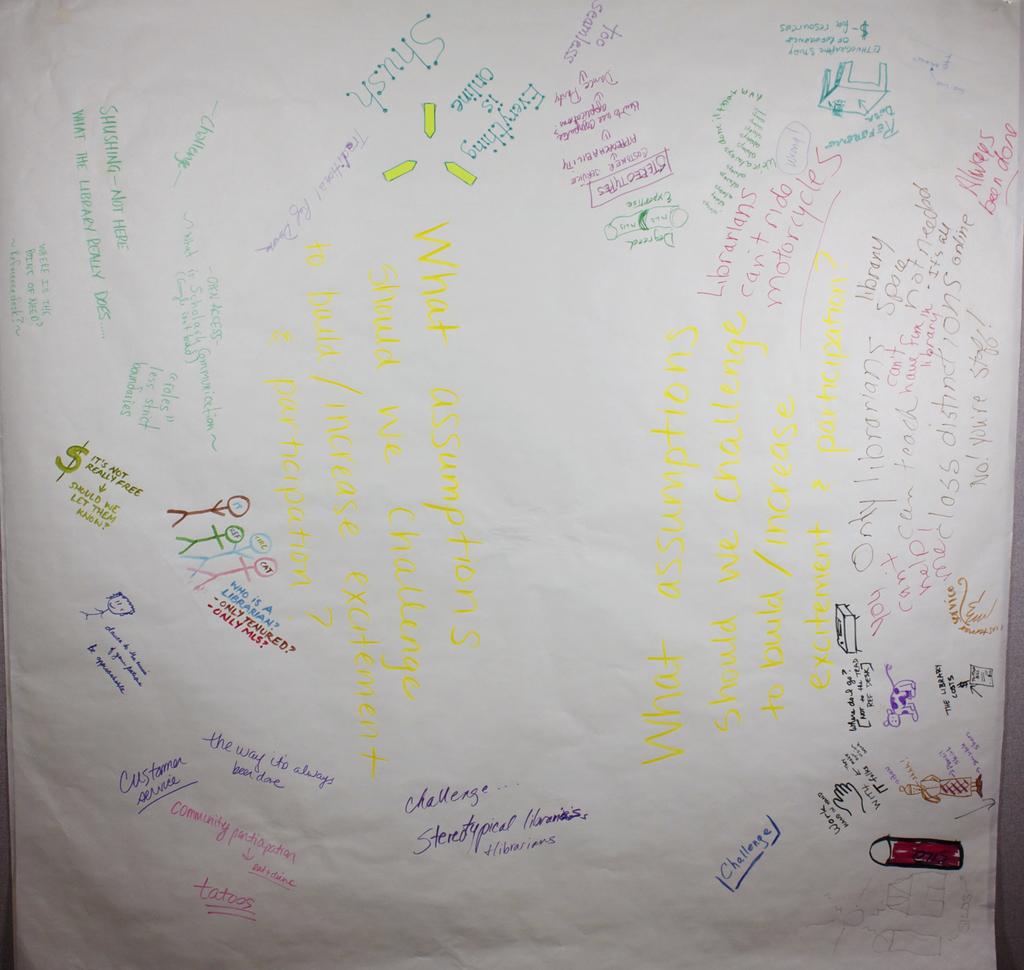What word is in half a box on the bottom right just to the left of the red pen?
Give a very brief answer. Challenge. 